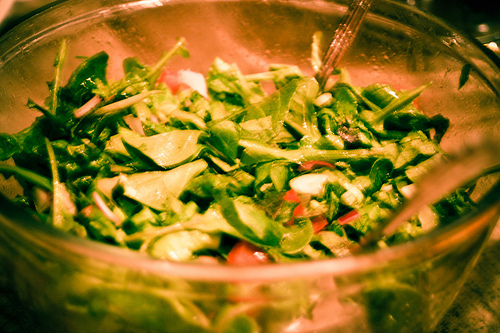<image>
Is the bowl under the spins? Yes. The bowl is positioned underneath the spins, with the spins above it in the vertical space. 